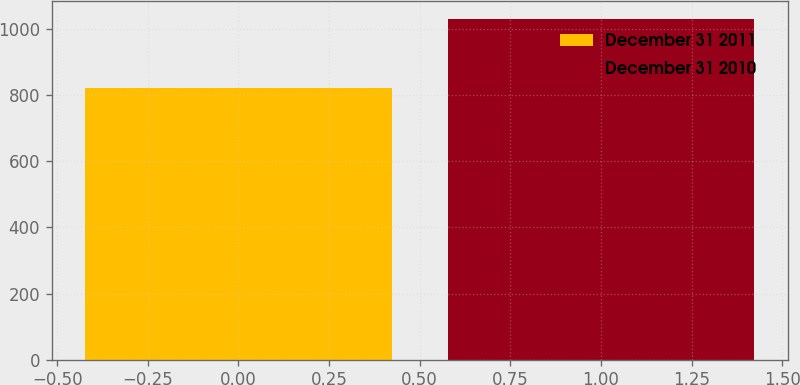Convert chart. <chart><loc_0><loc_0><loc_500><loc_500><bar_chart><fcel>December 31 2011<fcel>December 31 2010<nl><fcel>822.8<fcel>1031.2<nl></chart> 